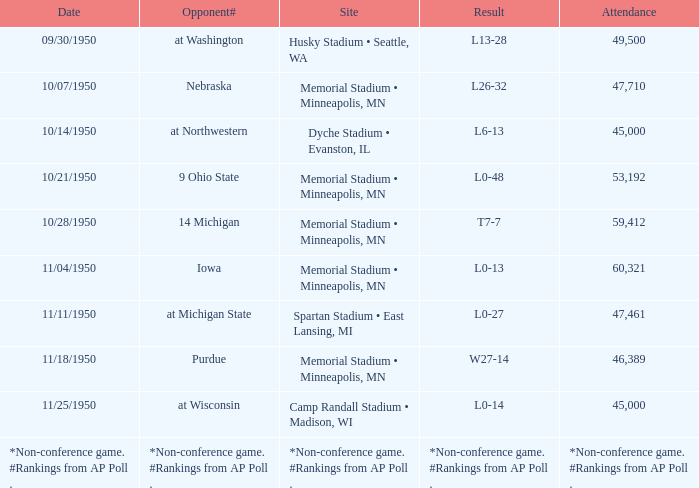On which date does the event take place at memorial stadium, minneapolis, mn, with an attendance of 53,192? 10/21/1950. 